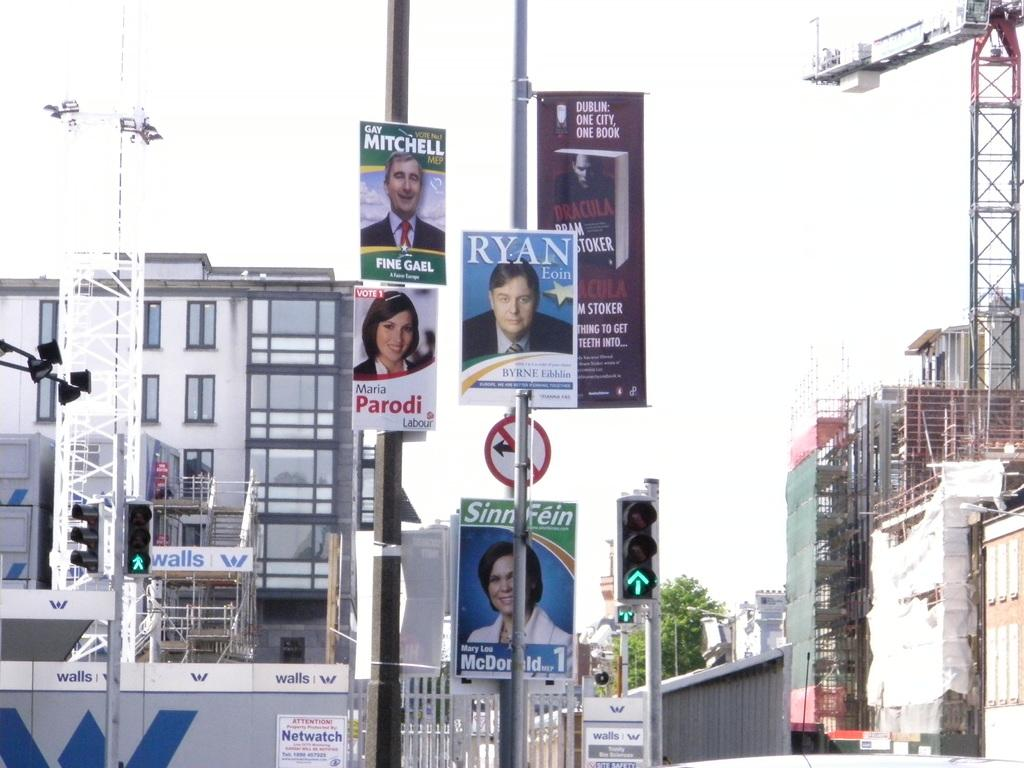<image>
Write a terse but informative summary of the picture. Political posters hanging off a pole promote candidates named Ryan, Mitchell and Parodi. 